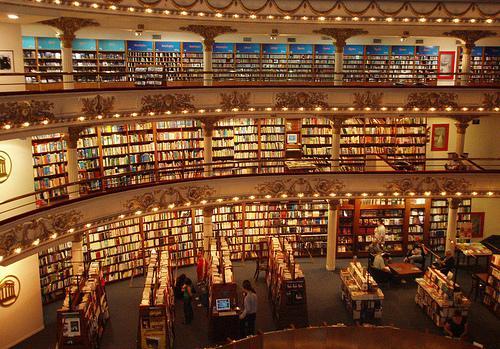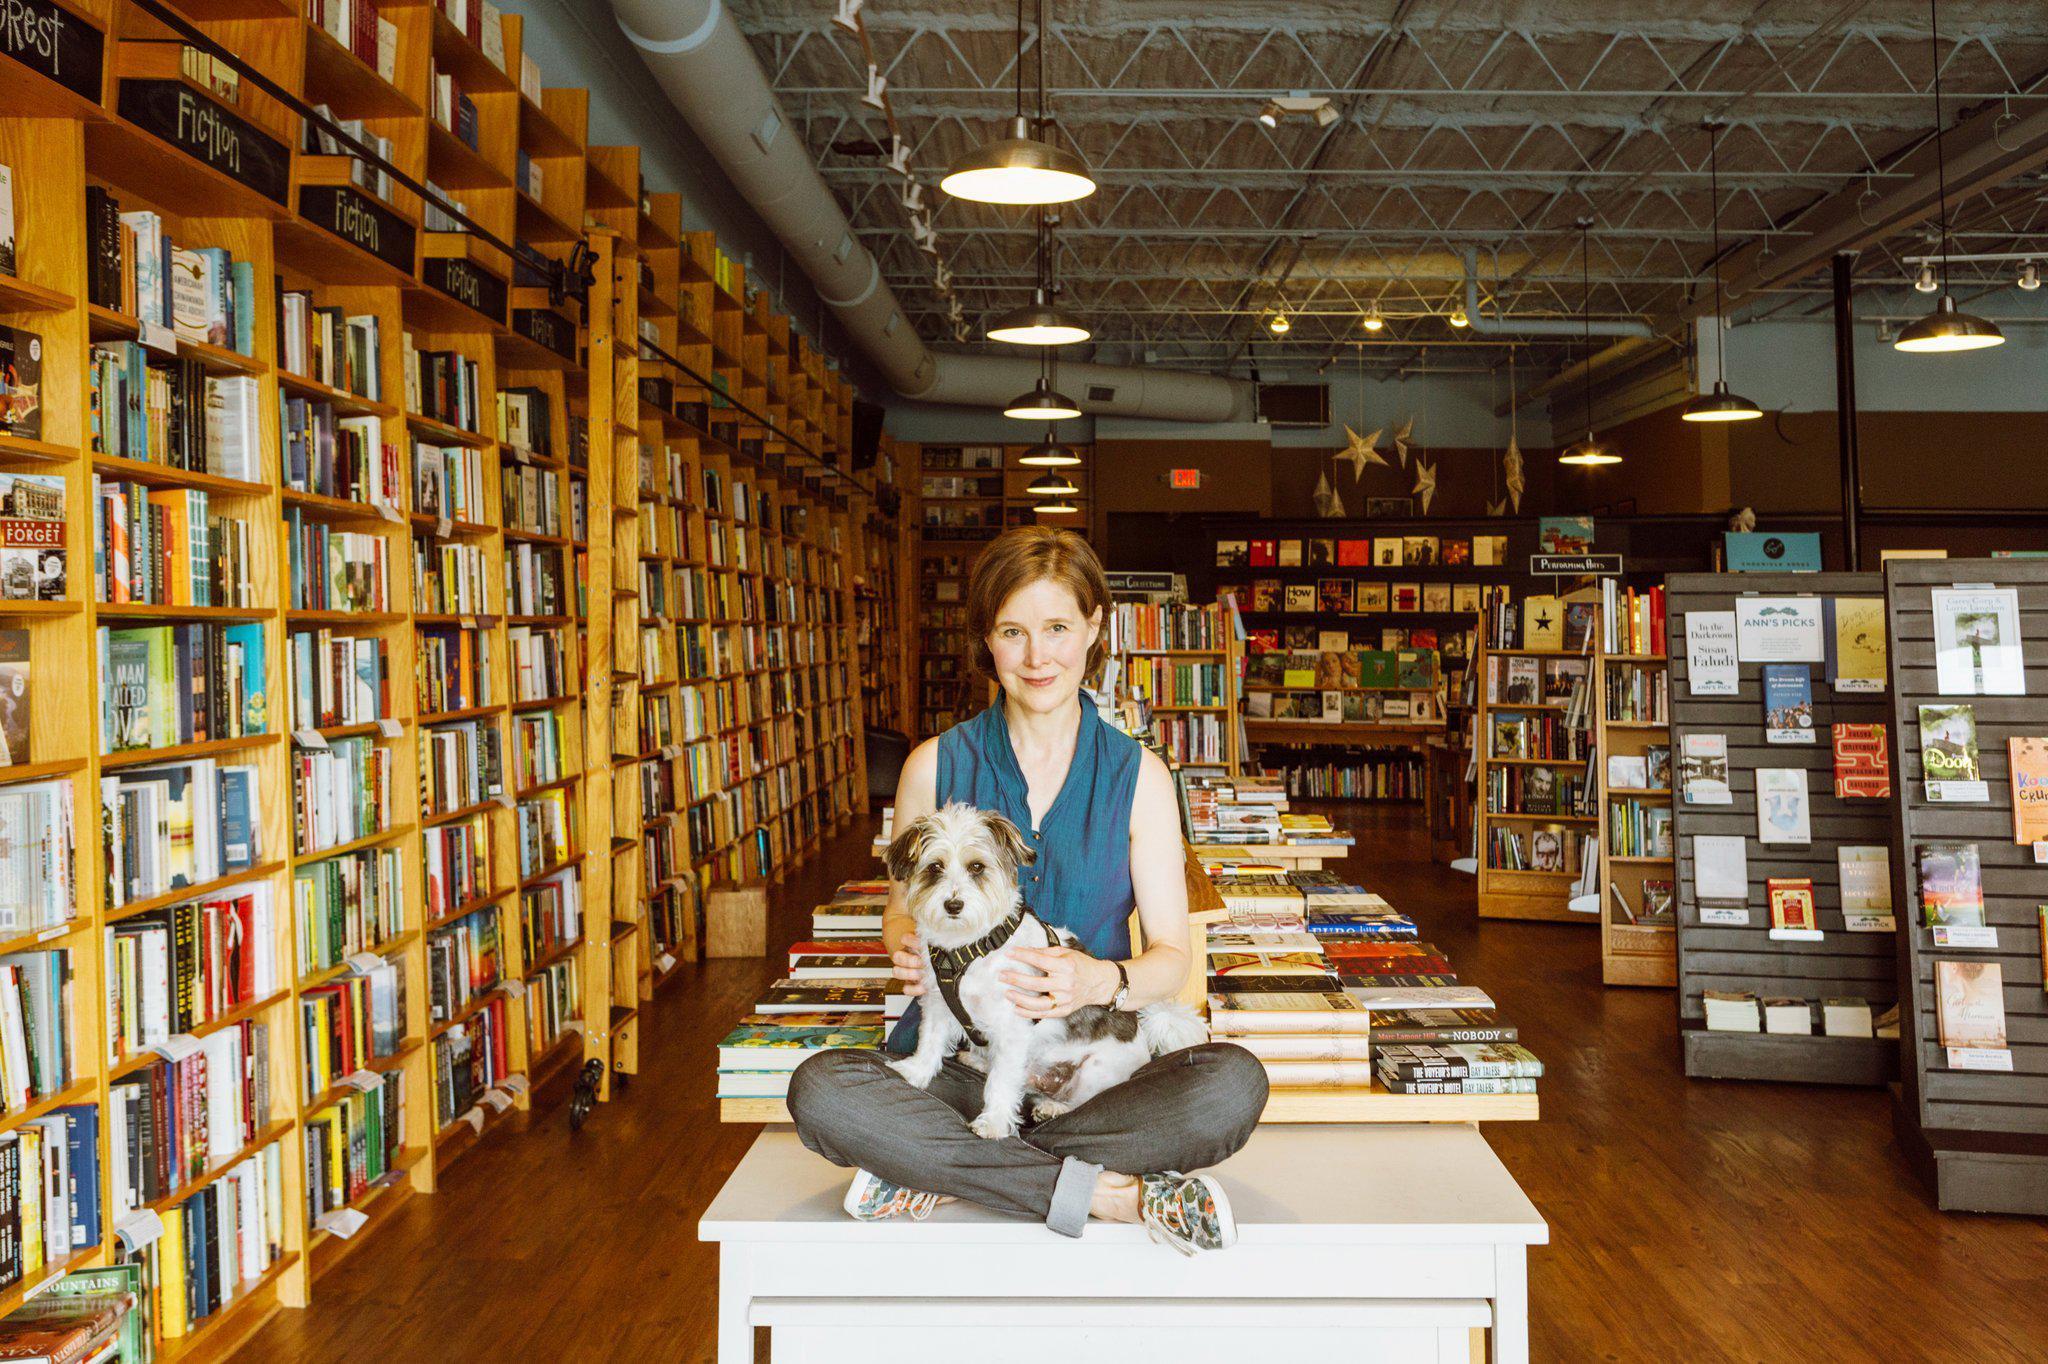The first image is the image on the left, the second image is the image on the right. For the images displayed, is the sentence "There is one woman wearing black in the lefthand image." factually correct? Answer yes or no. No. The first image is the image on the left, the second image is the image on the right. Examine the images to the left and right. Is the description "Left image contains a person wearing a black blazer." accurate? Answer yes or no. No. The first image is the image on the left, the second image is the image on the right. Examine the images to the left and right. Is the description "there is exactly one person in the image on the left" accurate? Answer yes or no. No. The first image is the image on the left, the second image is the image on the right. Assess this claim about the two images: "A woman with dark hair and wearing a black jacket is in a bookstore in one image.". Correct or not? Answer yes or no. No. 